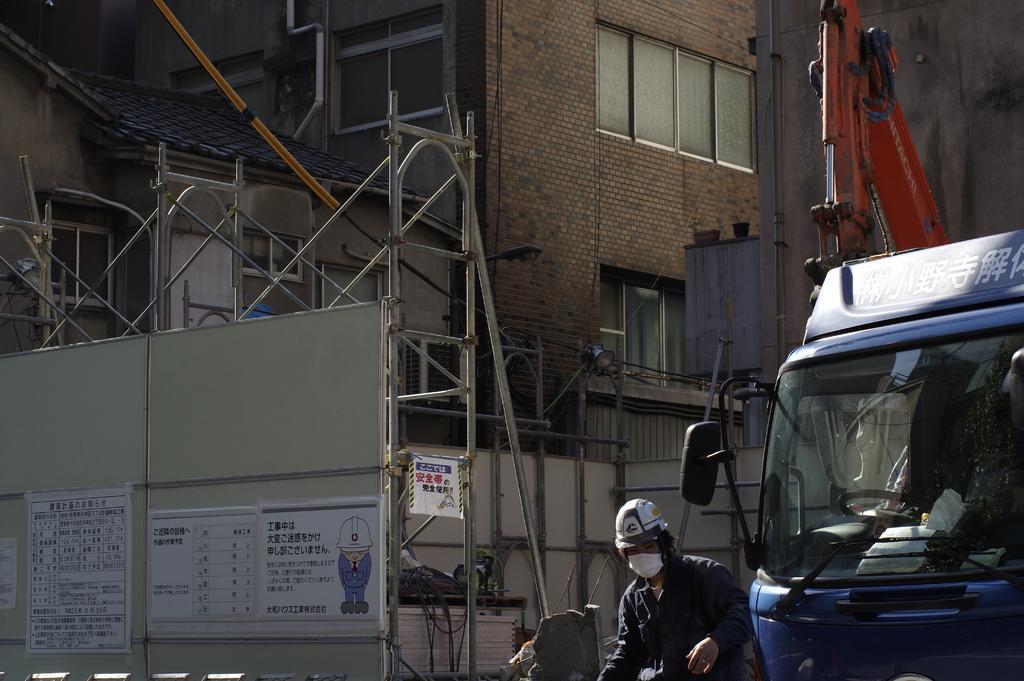Describe this image in one or two sentences. In this image I can see few vehicles. In front I can see the person and the person is wearing black color dress. In the background I can see the ladder, few poles and the building is in brown color and I can also see few glass windows. 